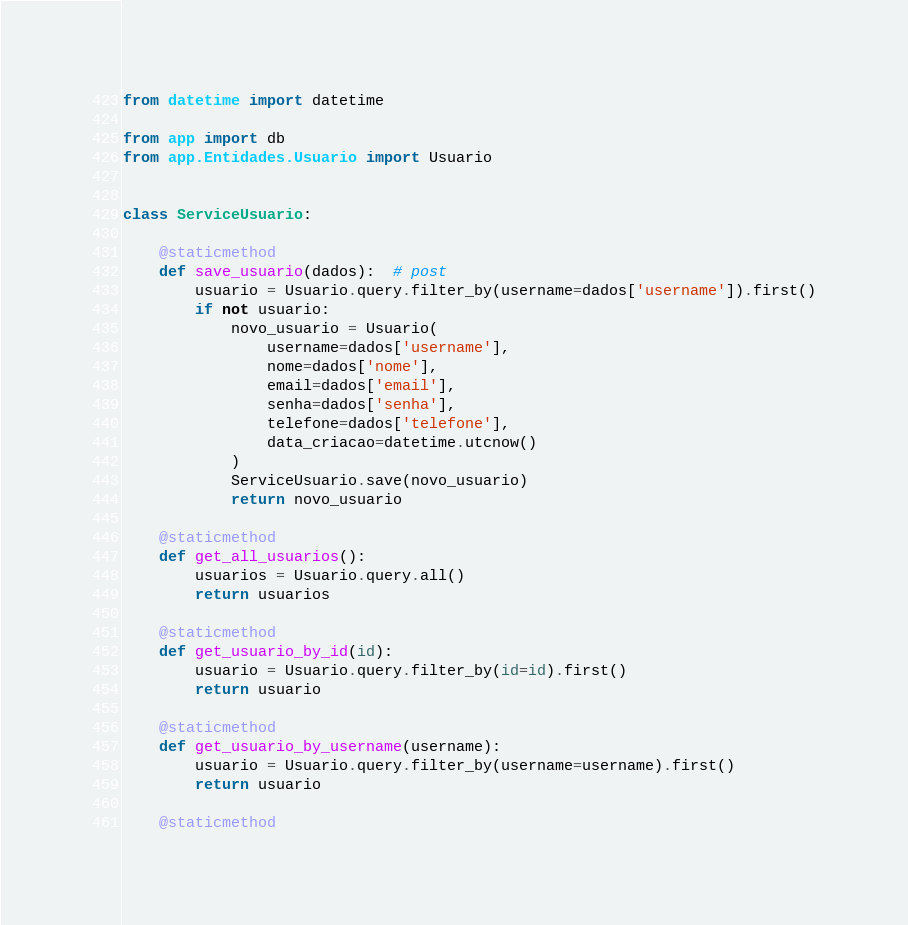Convert code to text. <code><loc_0><loc_0><loc_500><loc_500><_Python_>from datetime import datetime

from app import db
from app.Entidades.Usuario import Usuario


class ServiceUsuario:

    @staticmethod
    def save_usuario(dados):  # post
        usuario = Usuario.query.filter_by(username=dados['username']).first()
        if not usuario:
            novo_usuario = Usuario(
                username=dados['username'],
                nome=dados['nome'],
                email=dados['email'],
                senha=dados['senha'],
                telefone=dados['telefone'],
                data_criacao=datetime.utcnow()
            )
            ServiceUsuario.save(novo_usuario)
            return novo_usuario

    @staticmethod
    def get_all_usuarios():
        usuarios = Usuario.query.all()
        return usuarios

    @staticmethod
    def get_usuario_by_id(id):
        usuario = Usuario.query.filter_by(id=id).first()
        return usuario

    @staticmethod
    def get_usuario_by_username(username):
        usuario = Usuario.query.filter_by(username=username).first()
        return usuario

    @staticmethod</code> 